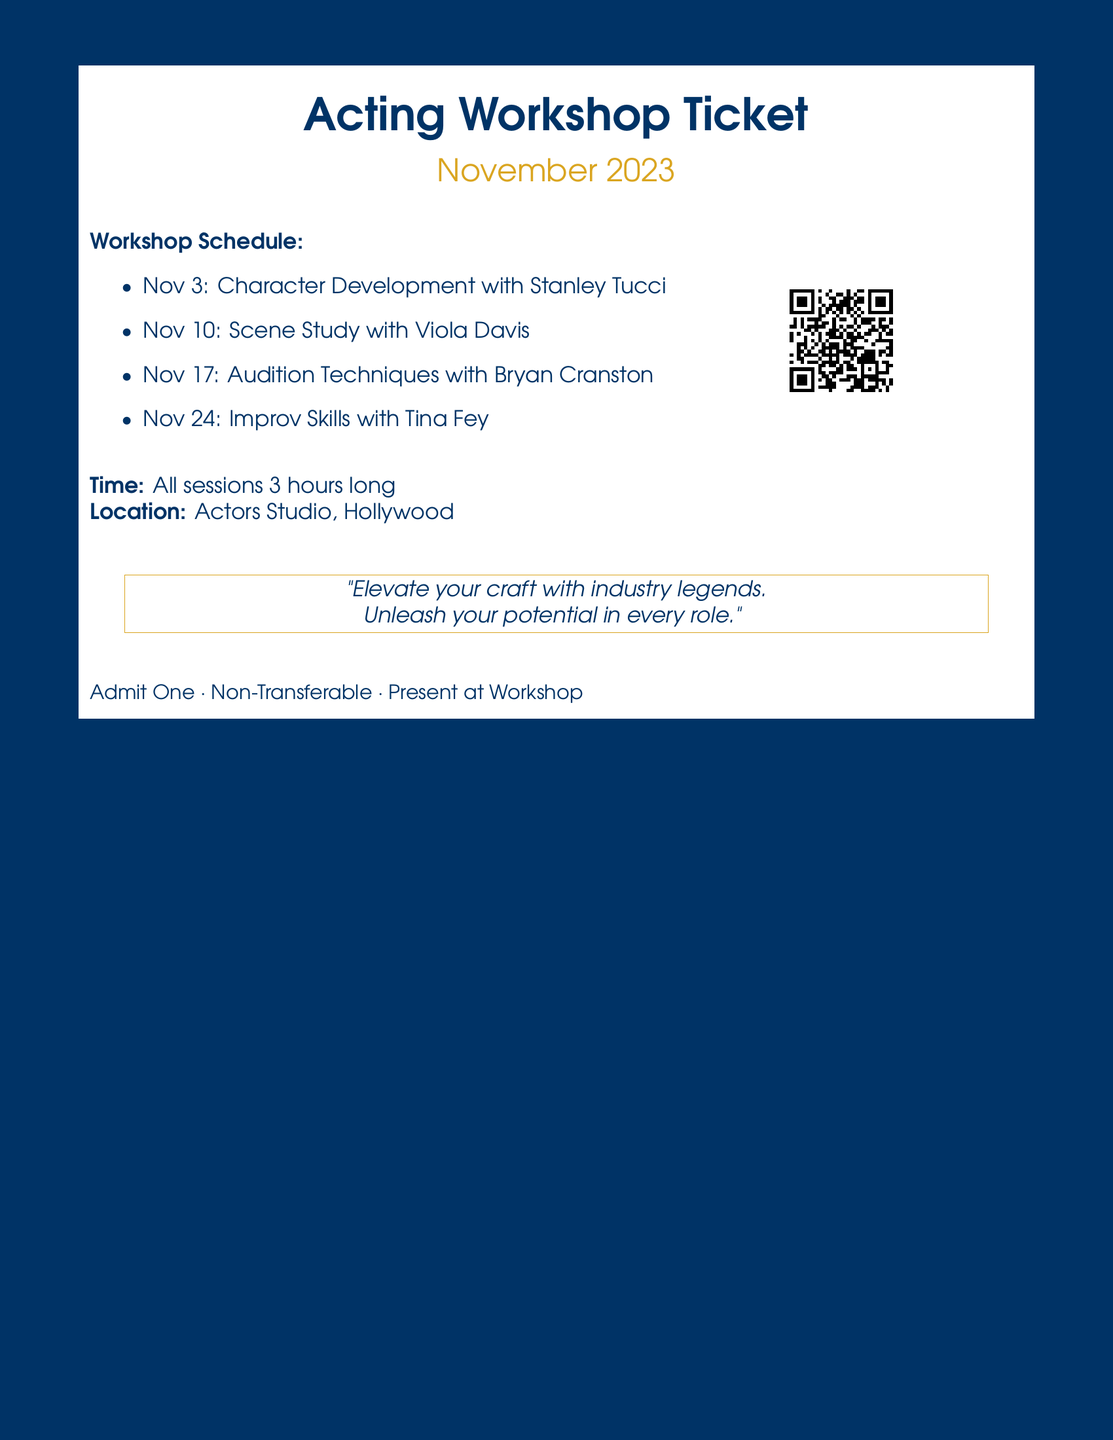What is the first workshop date? The first workshop listed in the schedule is on November 3rd, 2023.
Answer: November 3 Who is the guest coach for Scene Study? The document states that the guest coach for Scene Study is Viola Davis.
Answer: Viola Davis How long is each workshop session? The document specifies that all sessions are 3 hours long.
Answer: 3 hours What is the location of the workshops? The location provided in the document is the Actors Studio, Hollywood.
Answer: Actors Studio, Hollywood Which workshop focuses on Audition Techniques? The document indicates that the workshop focusing on Audition Techniques is with Bryan Cranston.
Answer: Bryan Cranston What is the color of the document's background? The background color of the document is deep blue.
Answer: Deep blue How many workshops are scheduled in November? The schedule lists a total of four workshops for the month of November.
Answer: Four What is the theme of the document's quote? The quote encourages elevation of craft and unleashing potential through workshops.
Answer: Elevate your craft 